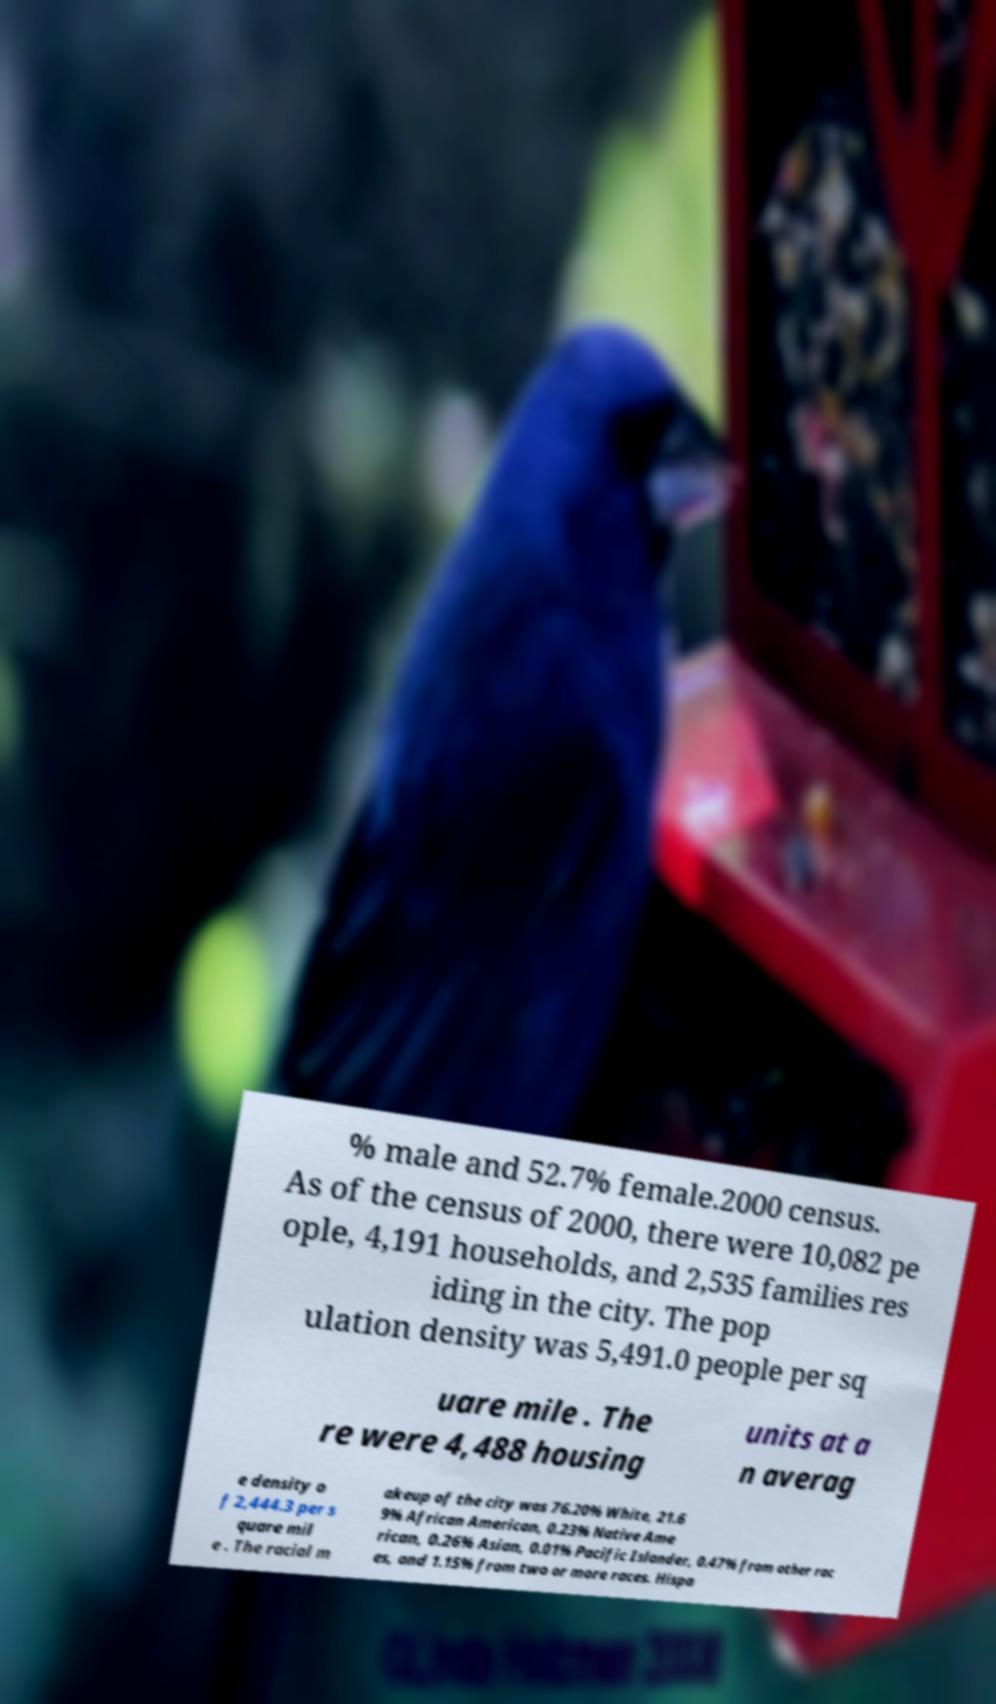I need the written content from this picture converted into text. Can you do that? % male and 52.7% female.2000 census. As of the census of 2000, there were 10,082 pe ople, 4,191 households, and 2,535 families res iding in the city. The pop ulation density was 5,491.0 people per sq uare mile . The re were 4,488 housing units at a n averag e density o f 2,444.3 per s quare mil e . The racial m akeup of the city was 76.20% White, 21.6 9% African American, 0.23% Native Ame rican, 0.26% Asian, 0.01% Pacific Islander, 0.47% from other rac es, and 1.15% from two or more races. Hispa 